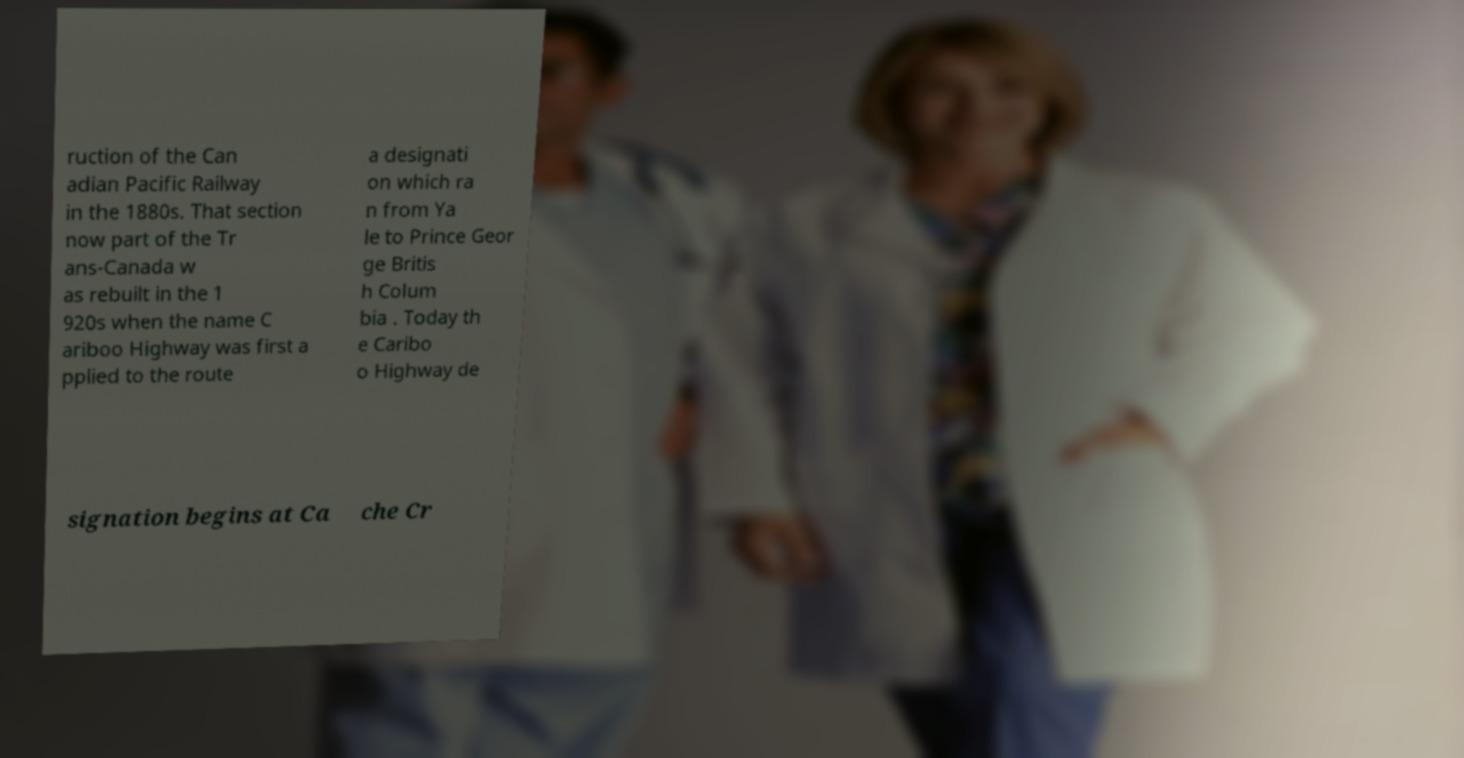Can you accurately transcribe the text from the provided image for me? ruction of the Can adian Pacific Railway in the 1880s. That section now part of the Tr ans-Canada w as rebuilt in the 1 920s when the name C ariboo Highway was first a pplied to the route a designati on which ra n from Ya le to Prince Geor ge Britis h Colum bia . Today th e Caribo o Highway de signation begins at Ca che Cr 